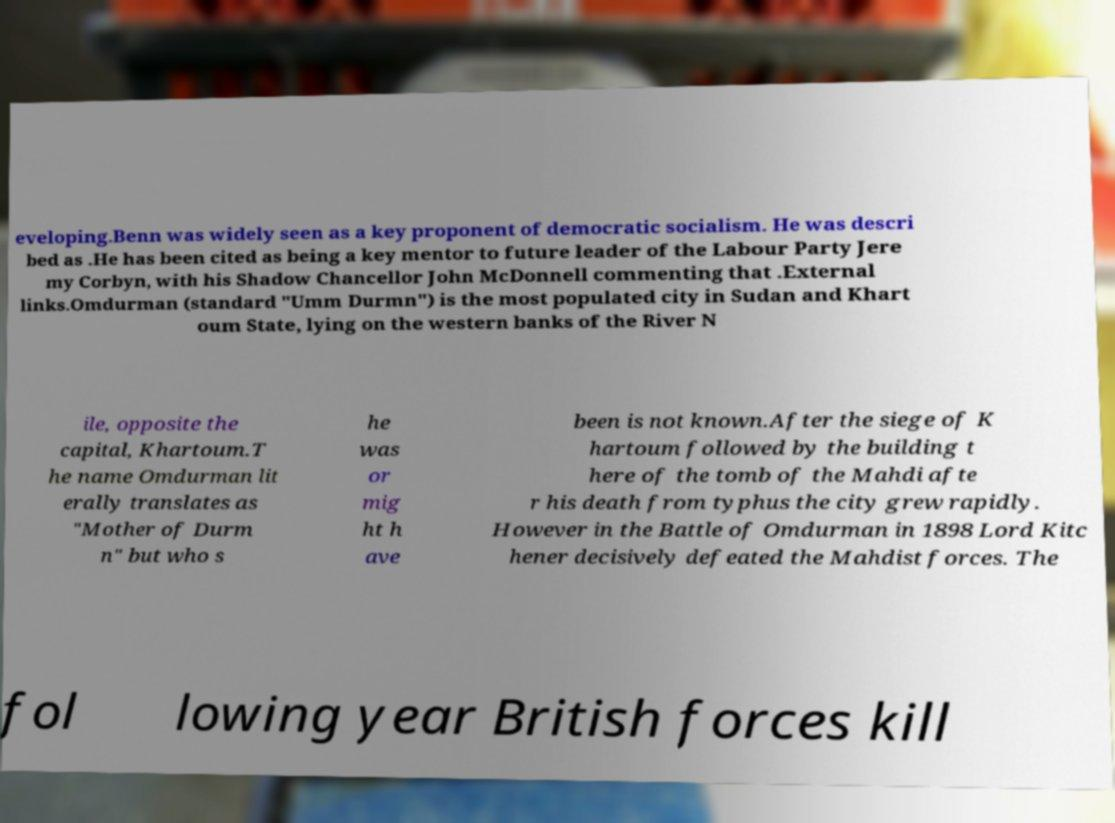Please read and relay the text visible in this image. What does it say? eveloping.Benn was widely seen as a key proponent of democratic socialism. He was descri bed as .He has been cited as being a key mentor to future leader of the Labour Party Jere my Corbyn, with his Shadow Chancellor John McDonnell commenting that .External links.Omdurman (standard "Umm Durmn") is the most populated city in Sudan and Khart oum State, lying on the western banks of the River N ile, opposite the capital, Khartoum.T he name Omdurman lit erally translates as "Mother of Durm n" but who s he was or mig ht h ave been is not known.After the siege of K hartoum followed by the building t here of the tomb of the Mahdi afte r his death from typhus the city grew rapidly. However in the Battle of Omdurman in 1898 Lord Kitc hener decisively defeated the Mahdist forces. The fol lowing year British forces kill 